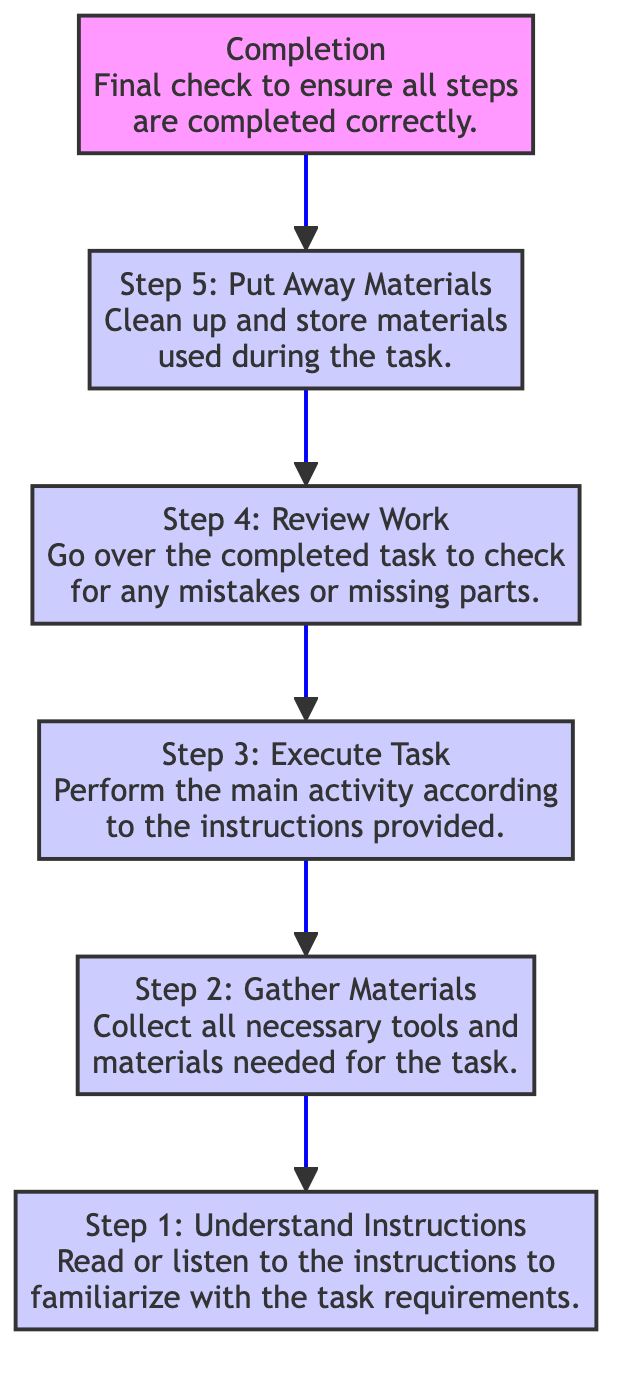What is the final step in the flow chart? The final step listed in the flow chart is "Completion." This indicates it is the last action to take once all previous steps have been finished.
Answer: Completion How many steps are in the task analysis? By counting the steps listed in the flow chart, there are a total of six steps, from understanding instructions to completing the task.
Answer: 6 What is the description of Step 3? Step 3 is labeled "Execute Task," and its description reads, "Perform the main activity according to the instructions provided." This step emphasizes actively carrying out what has been instructed.
Answer: Perform the main activity according to the instructions provided Which step follows "Review Work"? After "Review Work," which is Step 4, the next step in the flow chart is Step 5, labeled "Put Away Materials." This shows the progression from reviewing to cleaning up.
Answer: Step 5: Put Away Materials What should be done after "Gather Materials"? Following "Gather Materials," which is Step 2, the next action to take is "Execute Task." This means that once materials have been collected, the task can be carried out.
Answer: Execute Task How does Step 1 influence the overall flow? Step 1, "Understand Instructions," is the starting point of the flow chart, which sets the foundation for succeeding steps. If this step is not completed effectively, it can hinder the execution of all subsequent steps.
Answer: It sets the foundation for succeeding steps 